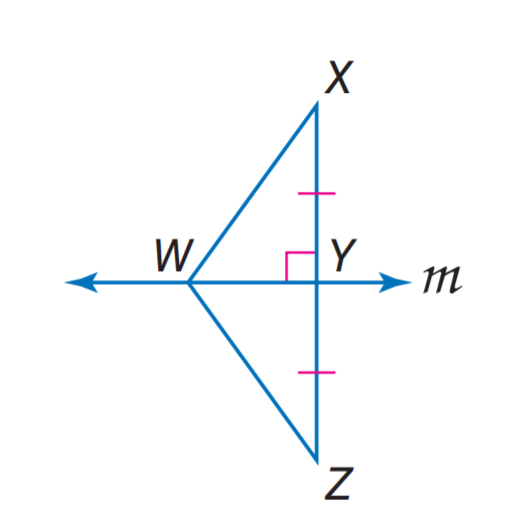Question: m is the perpendicular bisector of X Z, W Z = 4 a - 15 and W Z = a + 12. Find W X.
Choices:
A. 12
B. 15
C. 21
D. 22.4
Answer with the letter. Answer: C Question: If W Z = 25.3, Y Z = 22.4, W Z = 25.3, find X Y.
Choices:
A. 14.9
B. 21
C. 22.4
D. 25.3
Answer with the letter. Answer: C 